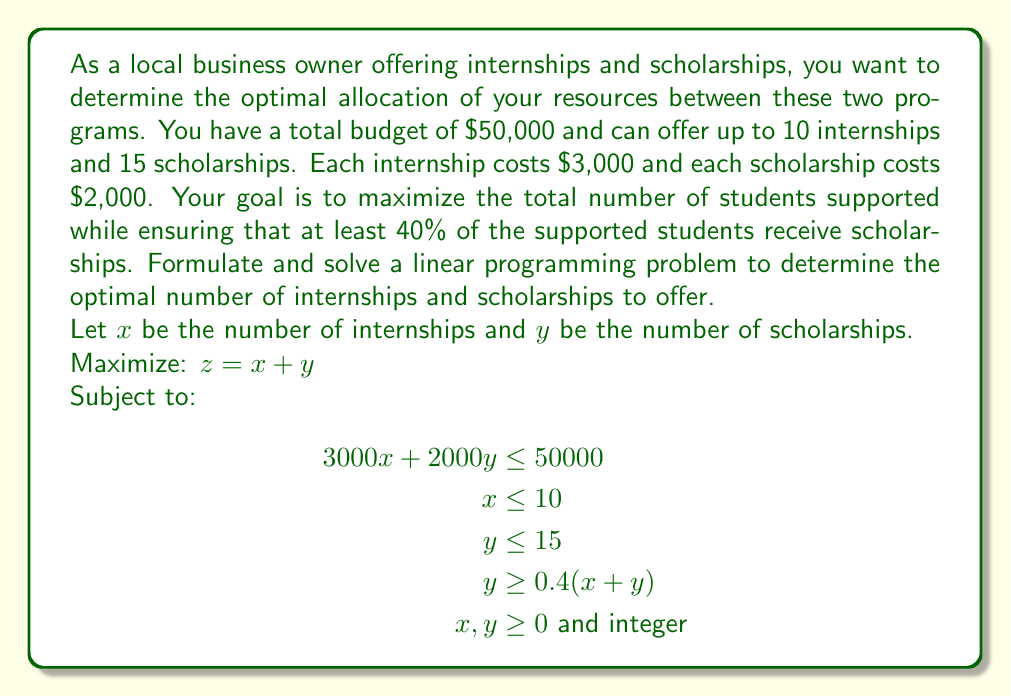Show me your answer to this math problem. To solve this linear programming problem, we'll follow these steps:

1) First, let's simplify the constraint $y \geq 0.4(x + y)$:
   $y \geq 0.4x + 0.4y$
   $0.6y \geq 0.4x$
   $y \geq \frac{2}{3}x$

2) Now our system of inequalities is:
   $$\begin{aligned}
   3000x + 2000y &\leq 50000 \\
   x &\leq 10 \\
   y &\leq 15 \\
   y &\geq \frac{2}{3}x \\
   x, y &\geq 0 \text{ and integer}
   \end{aligned}$$

3) We can solve this graphically by plotting these constraints:

   [asy]
   import geometry;

   size(200);
   
   xlimits(0,20);
   ylimits(0,20);
   
   xaxis("x",arrow=Arrow);
   yaxis("y",arrow=Arrow);
   
   path budget = (0,25)--(50/3,0);
   path max_x = (10,0)--(10,20);
   path max_y = (0,15)--(20,15);
   path ratio = (0,0)--(30,20);
   
   draw(budget,blue);
   draw(max_x,red);
   draw(max_y,green);
   draw(ratio,purple);
   
   label("Budget constraint",budget,NE);
   label("Max internships",max_x,E);
   label("Max scholarships",max_y,E);
   label("Ratio constraint",ratio,SE);
   
   dot((10,15));
   dot((50/3,0));
   dot((0,25));
   dot((15,10));
   
   label("(10,15)",(10,15),NE);
   label("(16.67,0)",(50/3,0),SE);
   label("(0,25)",(0,25),NW);
   label("(15,10)",(15,10),NE);
   [/asy]

4) The feasible region is the area bounded by these lines. The optimal solution will be at one of the corner points of this region.

5) We need to check the integer points near these corners:
   (10,15), (15,10), (16,0), (0,25)

6) Evaluating our objective function $z = x + y$ at these points:
   (10,15): $z = 25$
   (15,10): $z = 25$ (but this violates the $x \leq 10$ constraint)
   (16,0): $z = 16$ (but this violates the $x \leq 10$ constraint)
   (0,25): $z = 25$ (but this violates the $y \leq 15$ constraint)

7) The optimal integer solution that satisfies all constraints is (10,15).
Answer: The optimal allocation is to offer 10 internships and 15 scholarships, supporting a total of 25 students. 